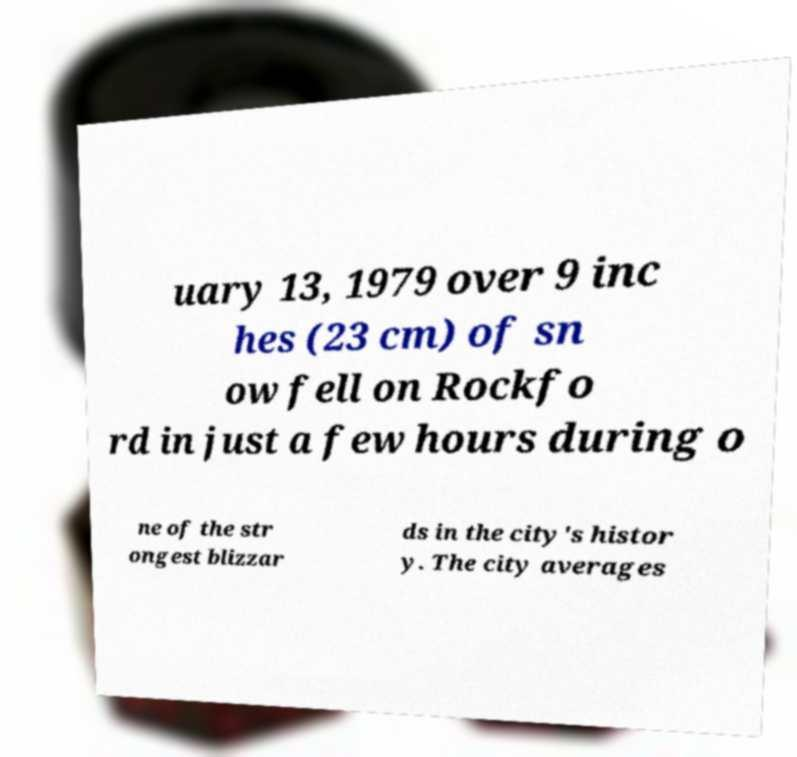Please identify and transcribe the text found in this image. uary 13, 1979 over 9 inc hes (23 cm) of sn ow fell on Rockfo rd in just a few hours during o ne of the str ongest blizzar ds in the city's histor y. The city averages 